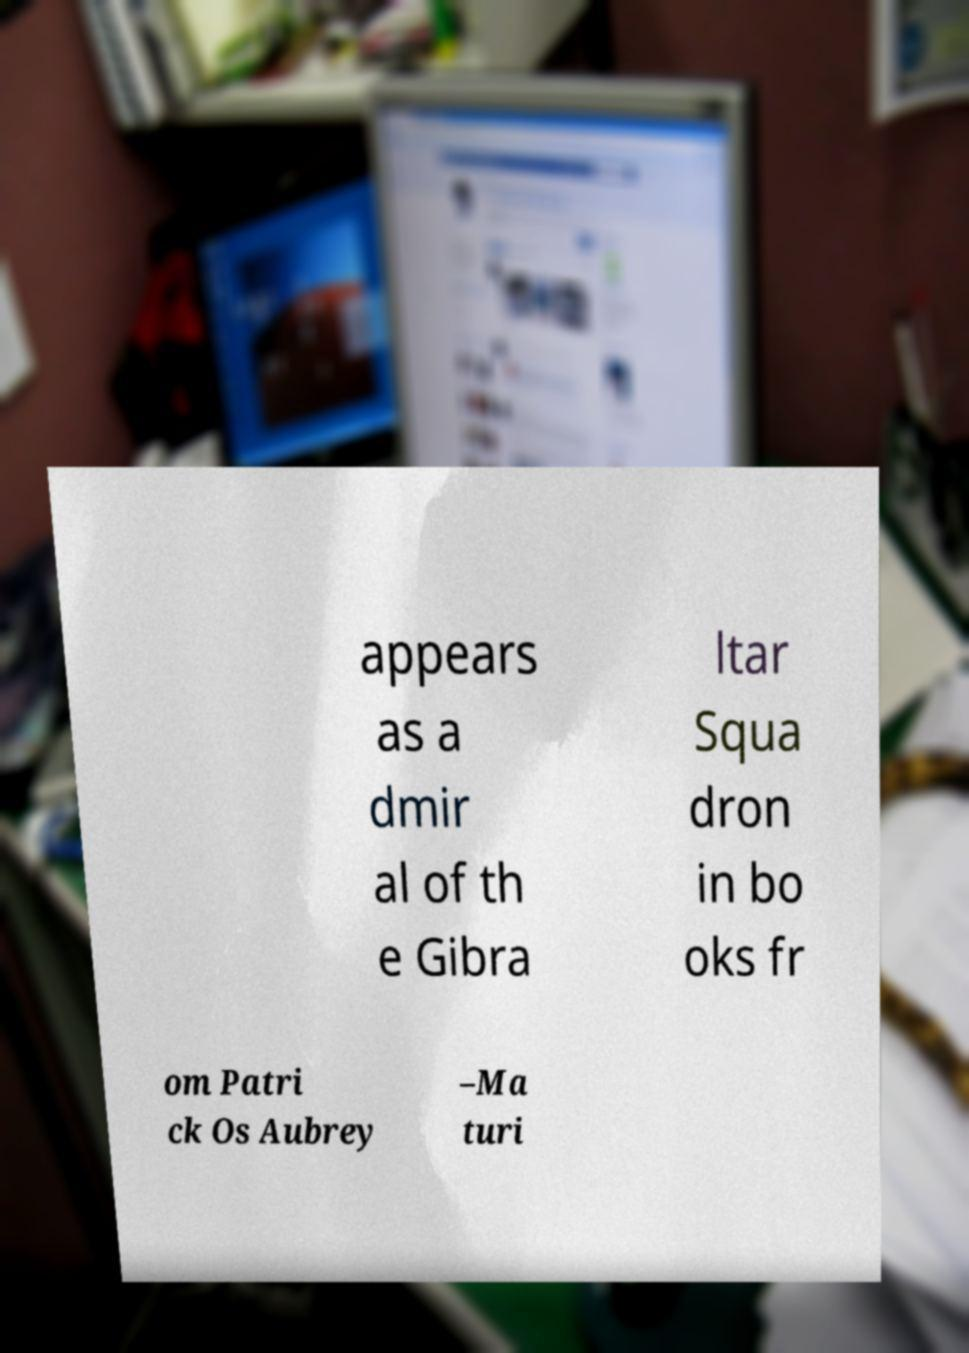What messages or text are displayed in this image? I need them in a readable, typed format. appears as a dmir al of th e Gibra ltar Squa dron in bo oks fr om Patri ck Os Aubrey –Ma turi 